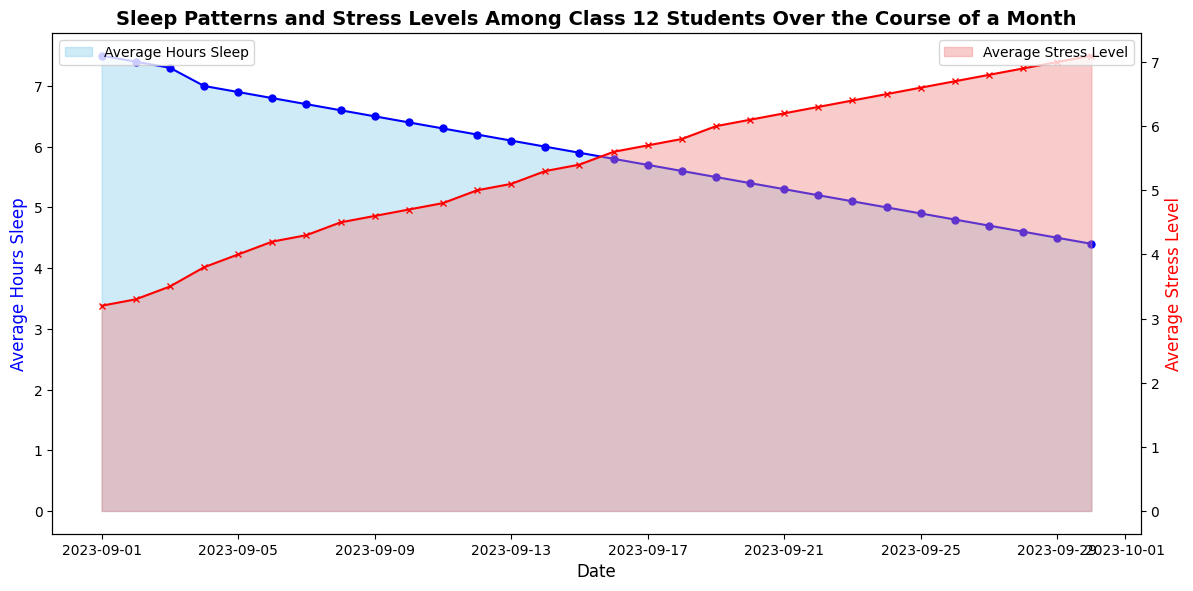What's the average number of hours slept on the first and last day of the month? To find the average, add the hours of sleep for the first and last day and divide by 2. On September 1st, students slept 7.5 hours, and on September 30th, they slept 4.4 hours. The average is (7.5 + 4.4) / 2 = 5.95 hours.
Answer: 5.95 hours Which date shows the highest average stress level? To determine this, look at the highest point on the plot for average stress levels. The peak stress level is on September 30th with a value of 7.1.
Answer: September 30th What is the trend in the average stress level from September 1st to September 30th? To determine the trend, observe the slope and pattern. The average stress level starts at 3.2 and increases steadily throughout the month, reaching 7.1. The trend is an upward slope.
Answer: Increasing How many days in the month did the average sleep hours fall below 6 hours? Count the number of days where the plot shows average hours of sleep below 6 hours. From September 14th to September 30th, which are 17 days, the sleep hours are below 6 hours.
Answer: 17 days Compare the average sleep hours and stress levels on September 15th. Which is higher? On September 15th, the average sleep hours are 5.9, and the stress level is 5.4. The stress level is higher.
Answer: Stress level On which date does the average sleep hours first drop below 7 hours? Track the plot from the beginning and identify when the average sleep drops below 7 hours. It first drops below 7 hours on September 4th.
Answer: September 4th What is the difference in average stress levels between September 10th and September 20th? Locate the stress levels on September 10th (4.7) and September 20th (6.1). The difference is 6.1 - 4.7 = 1.4.
Answer: 1.4 How does the color of the two plots help in distinguishing sleep hours and stress levels? The different colors in the plot help in distinguishing the two metrics. The sleep hours are represented by the blue color, and the stress levels are represented by the red color.
Answer: Blue for sleep, red for stress Is there any date where the average hours of sleep and stress levels are equal? By examining the plot, there is no date where the sleep hours and stress levels intersect or are equal, indicating they are always different values.
Answer: No Calculate the average sleep hours for the first week (September 1-7). Sum the average sleep hours for each day from September 1 to September 7 and divide by 7. The sum is 7.5 + 7.4 + 7.3 + 7.0 + 6.9 + 6.8 + 6.7 = 49.6. Dividing by 7 gives 49.6 / 7 ≈ 7.09 hours.
Answer: 7.09 hours 